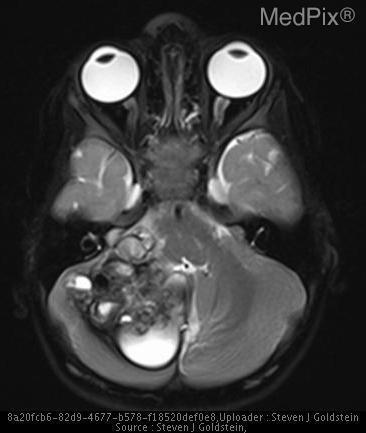What is the signal intensity of the lesion?
Quick response, please. Mixed intensity. How would you describe the lesions?
Answer briefly. Loculated. What is one adjective to describe the lesion(s)?
Write a very short answer. Loculated. What area is abnormal?
Concise answer only. Right cerebellum. Where is/are the abnormality located?
Be succinct. Right cerebellum. Are the findings normal?
Give a very brief answer. No. Is this image normal?
Be succinct. No. 